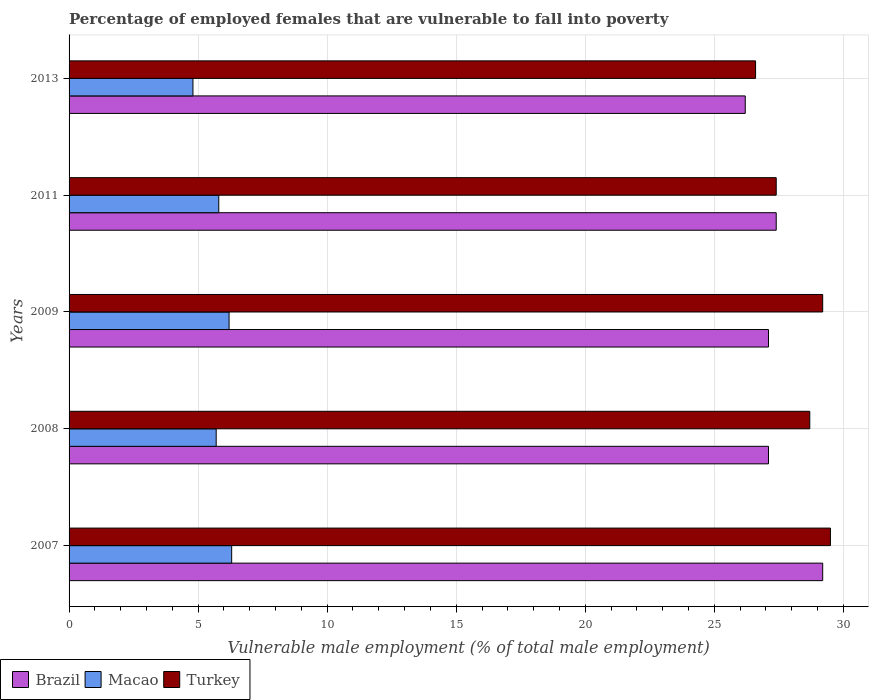How many groups of bars are there?
Your answer should be very brief. 5. Are the number of bars per tick equal to the number of legend labels?
Make the answer very short. Yes. Are the number of bars on each tick of the Y-axis equal?
Your answer should be very brief. Yes. How many bars are there on the 3rd tick from the bottom?
Make the answer very short. 3. In how many cases, is the number of bars for a given year not equal to the number of legend labels?
Offer a terse response. 0. What is the percentage of employed females who are vulnerable to fall into poverty in Brazil in 2008?
Your answer should be compact. 27.1. Across all years, what is the maximum percentage of employed females who are vulnerable to fall into poverty in Macao?
Provide a short and direct response. 6.3. Across all years, what is the minimum percentage of employed females who are vulnerable to fall into poverty in Brazil?
Provide a succinct answer. 26.2. In which year was the percentage of employed females who are vulnerable to fall into poverty in Brazil maximum?
Ensure brevity in your answer.  2007. What is the total percentage of employed females who are vulnerable to fall into poverty in Brazil in the graph?
Offer a terse response. 137. What is the difference between the percentage of employed females who are vulnerable to fall into poverty in Macao in 2007 and that in 2008?
Give a very brief answer. 0.6. What is the difference between the percentage of employed females who are vulnerable to fall into poverty in Brazil in 2007 and the percentage of employed females who are vulnerable to fall into poverty in Macao in 2013?
Offer a very short reply. 24.4. What is the average percentage of employed females who are vulnerable to fall into poverty in Brazil per year?
Keep it short and to the point. 27.4. In the year 2007, what is the difference between the percentage of employed females who are vulnerable to fall into poverty in Turkey and percentage of employed females who are vulnerable to fall into poverty in Macao?
Your response must be concise. 23.2. What is the ratio of the percentage of employed females who are vulnerable to fall into poverty in Brazil in 2008 to that in 2011?
Your response must be concise. 0.99. Is the percentage of employed females who are vulnerable to fall into poverty in Turkey in 2008 less than that in 2013?
Your answer should be very brief. No. Is the difference between the percentage of employed females who are vulnerable to fall into poverty in Turkey in 2007 and 2013 greater than the difference between the percentage of employed females who are vulnerable to fall into poverty in Macao in 2007 and 2013?
Ensure brevity in your answer.  Yes. What is the difference between the highest and the second highest percentage of employed females who are vulnerable to fall into poverty in Macao?
Provide a succinct answer. 0.1. In how many years, is the percentage of employed females who are vulnerable to fall into poverty in Brazil greater than the average percentage of employed females who are vulnerable to fall into poverty in Brazil taken over all years?
Make the answer very short. 1. What does the 2nd bar from the top in 2008 represents?
Give a very brief answer. Macao. Does the graph contain any zero values?
Offer a very short reply. No. Where does the legend appear in the graph?
Keep it short and to the point. Bottom left. What is the title of the graph?
Your answer should be compact. Percentage of employed females that are vulnerable to fall into poverty. What is the label or title of the X-axis?
Ensure brevity in your answer.  Vulnerable male employment (% of total male employment). What is the Vulnerable male employment (% of total male employment) of Brazil in 2007?
Offer a very short reply. 29.2. What is the Vulnerable male employment (% of total male employment) in Macao in 2007?
Keep it short and to the point. 6.3. What is the Vulnerable male employment (% of total male employment) of Turkey in 2007?
Make the answer very short. 29.5. What is the Vulnerable male employment (% of total male employment) of Brazil in 2008?
Offer a very short reply. 27.1. What is the Vulnerable male employment (% of total male employment) in Macao in 2008?
Your response must be concise. 5.7. What is the Vulnerable male employment (% of total male employment) of Turkey in 2008?
Keep it short and to the point. 28.7. What is the Vulnerable male employment (% of total male employment) in Brazil in 2009?
Make the answer very short. 27.1. What is the Vulnerable male employment (% of total male employment) of Macao in 2009?
Make the answer very short. 6.2. What is the Vulnerable male employment (% of total male employment) of Turkey in 2009?
Your answer should be compact. 29.2. What is the Vulnerable male employment (% of total male employment) of Brazil in 2011?
Give a very brief answer. 27.4. What is the Vulnerable male employment (% of total male employment) in Macao in 2011?
Make the answer very short. 5.8. What is the Vulnerable male employment (% of total male employment) of Turkey in 2011?
Keep it short and to the point. 27.4. What is the Vulnerable male employment (% of total male employment) in Brazil in 2013?
Your response must be concise. 26.2. What is the Vulnerable male employment (% of total male employment) in Macao in 2013?
Provide a succinct answer. 4.8. What is the Vulnerable male employment (% of total male employment) of Turkey in 2013?
Ensure brevity in your answer.  26.6. Across all years, what is the maximum Vulnerable male employment (% of total male employment) of Brazil?
Offer a terse response. 29.2. Across all years, what is the maximum Vulnerable male employment (% of total male employment) of Macao?
Your answer should be very brief. 6.3. Across all years, what is the maximum Vulnerable male employment (% of total male employment) in Turkey?
Your answer should be compact. 29.5. Across all years, what is the minimum Vulnerable male employment (% of total male employment) of Brazil?
Keep it short and to the point. 26.2. Across all years, what is the minimum Vulnerable male employment (% of total male employment) of Macao?
Ensure brevity in your answer.  4.8. Across all years, what is the minimum Vulnerable male employment (% of total male employment) in Turkey?
Provide a short and direct response. 26.6. What is the total Vulnerable male employment (% of total male employment) of Brazil in the graph?
Make the answer very short. 137. What is the total Vulnerable male employment (% of total male employment) in Macao in the graph?
Offer a very short reply. 28.8. What is the total Vulnerable male employment (% of total male employment) of Turkey in the graph?
Give a very brief answer. 141.4. What is the difference between the Vulnerable male employment (% of total male employment) in Brazil in 2007 and that in 2008?
Give a very brief answer. 2.1. What is the difference between the Vulnerable male employment (% of total male employment) in Macao in 2007 and that in 2008?
Your answer should be compact. 0.6. What is the difference between the Vulnerable male employment (% of total male employment) in Macao in 2007 and that in 2009?
Make the answer very short. 0.1. What is the difference between the Vulnerable male employment (% of total male employment) of Brazil in 2007 and that in 2013?
Make the answer very short. 3. What is the difference between the Vulnerable male employment (% of total male employment) in Macao in 2008 and that in 2009?
Your answer should be very brief. -0.5. What is the difference between the Vulnerable male employment (% of total male employment) of Turkey in 2008 and that in 2009?
Your answer should be very brief. -0.5. What is the difference between the Vulnerable male employment (% of total male employment) of Macao in 2008 and that in 2011?
Provide a short and direct response. -0.1. What is the difference between the Vulnerable male employment (% of total male employment) in Turkey in 2008 and that in 2011?
Your answer should be very brief. 1.3. What is the difference between the Vulnerable male employment (% of total male employment) in Brazil in 2008 and that in 2013?
Offer a terse response. 0.9. What is the difference between the Vulnerable male employment (% of total male employment) in Macao in 2008 and that in 2013?
Offer a very short reply. 0.9. What is the difference between the Vulnerable male employment (% of total male employment) in Brazil in 2009 and that in 2011?
Offer a terse response. -0.3. What is the difference between the Vulnerable male employment (% of total male employment) of Macao in 2009 and that in 2011?
Offer a very short reply. 0.4. What is the difference between the Vulnerable male employment (% of total male employment) of Macao in 2009 and that in 2013?
Your answer should be compact. 1.4. What is the difference between the Vulnerable male employment (% of total male employment) of Turkey in 2009 and that in 2013?
Your response must be concise. 2.6. What is the difference between the Vulnerable male employment (% of total male employment) in Brazil in 2011 and that in 2013?
Your answer should be compact. 1.2. What is the difference between the Vulnerable male employment (% of total male employment) in Turkey in 2011 and that in 2013?
Make the answer very short. 0.8. What is the difference between the Vulnerable male employment (% of total male employment) in Brazil in 2007 and the Vulnerable male employment (% of total male employment) in Macao in 2008?
Offer a terse response. 23.5. What is the difference between the Vulnerable male employment (% of total male employment) of Brazil in 2007 and the Vulnerable male employment (% of total male employment) of Turkey in 2008?
Keep it short and to the point. 0.5. What is the difference between the Vulnerable male employment (% of total male employment) of Macao in 2007 and the Vulnerable male employment (% of total male employment) of Turkey in 2008?
Your answer should be compact. -22.4. What is the difference between the Vulnerable male employment (% of total male employment) in Brazil in 2007 and the Vulnerable male employment (% of total male employment) in Macao in 2009?
Ensure brevity in your answer.  23. What is the difference between the Vulnerable male employment (% of total male employment) of Brazil in 2007 and the Vulnerable male employment (% of total male employment) of Turkey in 2009?
Your response must be concise. 0. What is the difference between the Vulnerable male employment (% of total male employment) in Macao in 2007 and the Vulnerable male employment (% of total male employment) in Turkey in 2009?
Your answer should be very brief. -22.9. What is the difference between the Vulnerable male employment (% of total male employment) in Brazil in 2007 and the Vulnerable male employment (% of total male employment) in Macao in 2011?
Ensure brevity in your answer.  23.4. What is the difference between the Vulnerable male employment (% of total male employment) of Macao in 2007 and the Vulnerable male employment (% of total male employment) of Turkey in 2011?
Offer a terse response. -21.1. What is the difference between the Vulnerable male employment (% of total male employment) in Brazil in 2007 and the Vulnerable male employment (% of total male employment) in Macao in 2013?
Offer a terse response. 24.4. What is the difference between the Vulnerable male employment (% of total male employment) in Macao in 2007 and the Vulnerable male employment (% of total male employment) in Turkey in 2013?
Your response must be concise. -20.3. What is the difference between the Vulnerable male employment (% of total male employment) of Brazil in 2008 and the Vulnerable male employment (% of total male employment) of Macao in 2009?
Your response must be concise. 20.9. What is the difference between the Vulnerable male employment (% of total male employment) in Macao in 2008 and the Vulnerable male employment (% of total male employment) in Turkey in 2009?
Ensure brevity in your answer.  -23.5. What is the difference between the Vulnerable male employment (% of total male employment) in Brazil in 2008 and the Vulnerable male employment (% of total male employment) in Macao in 2011?
Your answer should be very brief. 21.3. What is the difference between the Vulnerable male employment (% of total male employment) in Macao in 2008 and the Vulnerable male employment (% of total male employment) in Turkey in 2011?
Make the answer very short. -21.7. What is the difference between the Vulnerable male employment (% of total male employment) in Brazil in 2008 and the Vulnerable male employment (% of total male employment) in Macao in 2013?
Your answer should be very brief. 22.3. What is the difference between the Vulnerable male employment (% of total male employment) in Brazil in 2008 and the Vulnerable male employment (% of total male employment) in Turkey in 2013?
Your answer should be very brief. 0.5. What is the difference between the Vulnerable male employment (% of total male employment) of Macao in 2008 and the Vulnerable male employment (% of total male employment) of Turkey in 2013?
Provide a succinct answer. -20.9. What is the difference between the Vulnerable male employment (% of total male employment) of Brazil in 2009 and the Vulnerable male employment (% of total male employment) of Macao in 2011?
Offer a terse response. 21.3. What is the difference between the Vulnerable male employment (% of total male employment) of Macao in 2009 and the Vulnerable male employment (% of total male employment) of Turkey in 2011?
Make the answer very short. -21.2. What is the difference between the Vulnerable male employment (% of total male employment) in Brazil in 2009 and the Vulnerable male employment (% of total male employment) in Macao in 2013?
Offer a terse response. 22.3. What is the difference between the Vulnerable male employment (% of total male employment) in Brazil in 2009 and the Vulnerable male employment (% of total male employment) in Turkey in 2013?
Provide a short and direct response. 0.5. What is the difference between the Vulnerable male employment (% of total male employment) in Macao in 2009 and the Vulnerable male employment (% of total male employment) in Turkey in 2013?
Offer a very short reply. -20.4. What is the difference between the Vulnerable male employment (% of total male employment) in Brazil in 2011 and the Vulnerable male employment (% of total male employment) in Macao in 2013?
Keep it short and to the point. 22.6. What is the difference between the Vulnerable male employment (% of total male employment) in Macao in 2011 and the Vulnerable male employment (% of total male employment) in Turkey in 2013?
Offer a terse response. -20.8. What is the average Vulnerable male employment (% of total male employment) in Brazil per year?
Offer a terse response. 27.4. What is the average Vulnerable male employment (% of total male employment) in Macao per year?
Ensure brevity in your answer.  5.76. What is the average Vulnerable male employment (% of total male employment) in Turkey per year?
Provide a short and direct response. 28.28. In the year 2007, what is the difference between the Vulnerable male employment (% of total male employment) of Brazil and Vulnerable male employment (% of total male employment) of Macao?
Your answer should be compact. 22.9. In the year 2007, what is the difference between the Vulnerable male employment (% of total male employment) of Brazil and Vulnerable male employment (% of total male employment) of Turkey?
Offer a very short reply. -0.3. In the year 2007, what is the difference between the Vulnerable male employment (% of total male employment) in Macao and Vulnerable male employment (% of total male employment) in Turkey?
Your answer should be very brief. -23.2. In the year 2008, what is the difference between the Vulnerable male employment (% of total male employment) in Brazil and Vulnerable male employment (% of total male employment) in Macao?
Keep it short and to the point. 21.4. In the year 2008, what is the difference between the Vulnerable male employment (% of total male employment) in Brazil and Vulnerable male employment (% of total male employment) in Turkey?
Make the answer very short. -1.6. In the year 2008, what is the difference between the Vulnerable male employment (% of total male employment) in Macao and Vulnerable male employment (% of total male employment) in Turkey?
Your answer should be very brief. -23. In the year 2009, what is the difference between the Vulnerable male employment (% of total male employment) of Brazil and Vulnerable male employment (% of total male employment) of Macao?
Provide a short and direct response. 20.9. In the year 2011, what is the difference between the Vulnerable male employment (% of total male employment) of Brazil and Vulnerable male employment (% of total male employment) of Macao?
Your answer should be compact. 21.6. In the year 2011, what is the difference between the Vulnerable male employment (% of total male employment) of Brazil and Vulnerable male employment (% of total male employment) of Turkey?
Offer a terse response. 0. In the year 2011, what is the difference between the Vulnerable male employment (% of total male employment) of Macao and Vulnerable male employment (% of total male employment) of Turkey?
Provide a succinct answer. -21.6. In the year 2013, what is the difference between the Vulnerable male employment (% of total male employment) of Brazil and Vulnerable male employment (% of total male employment) of Macao?
Your response must be concise. 21.4. In the year 2013, what is the difference between the Vulnerable male employment (% of total male employment) in Macao and Vulnerable male employment (% of total male employment) in Turkey?
Provide a succinct answer. -21.8. What is the ratio of the Vulnerable male employment (% of total male employment) of Brazil in 2007 to that in 2008?
Provide a short and direct response. 1.08. What is the ratio of the Vulnerable male employment (% of total male employment) in Macao in 2007 to that in 2008?
Ensure brevity in your answer.  1.11. What is the ratio of the Vulnerable male employment (% of total male employment) in Turkey in 2007 to that in 2008?
Your response must be concise. 1.03. What is the ratio of the Vulnerable male employment (% of total male employment) in Brazil in 2007 to that in 2009?
Offer a very short reply. 1.08. What is the ratio of the Vulnerable male employment (% of total male employment) of Macao in 2007 to that in 2009?
Provide a succinct answer. 1.02. What is the ratio of the Vulnerable male employment (% of total male employment) in Turkey in 2007 to that in 2009?
Offer a very short reply. 1.01. What is the ratio of the Vulnerable male employment (% of total male employment) in Brazil in 2007 to that in 2011?
Give a very brief answer. 1.07. What is the ratio of the Vulnerable male employment (% of total male employment) of Macao in 2007 to that in 2011?
Offer a very short reply. 1.09. What is the ratio of the Vulnerable male employment (% of total male employment) in Turkey in 2007 to that in 2011?
Your response must be concise. 1.08. What is the ratio of the Vulnerable male employment (% of total male employment) of Brazil in 2007 to that in 2013?
Make the answer very short. 1.11. What is the ratio of the Vulnerable male employment (% of total male employment) of Macao in 2007 to that in 2013?
Keep it short and to the point. 1.31. What is the ratio of the Vulnerable male employment (% of total male employment) in Turkey in 2007 to that in 2013?
Ensure brevity in your answer.  1.11. What is the ratio of the Vulnerable male employment (% of total male employment) of Brazil in 2008 to that in 2009?
Keep it short and to the point. 1. What is the ratio of the Vulnerable male employment (% of total male employment) in Macao in 2008 to that in 2009?
Provide a short and direct response. 0.92. What is the ratio of the Vulnerable male employment (% of total male employment) of Turkey in 2008 to that in 2009?
Ensure brevity in your answer.  0.98. What is the ratio of the Vulnerable male employment (% of total male employment) of Brazil in 2008 to that in 2011?
Offer a very short reply. 0.99. What is the ratio of the Vulnerable male employment (% of total male employment) of Macao in 2008 to that in 2011?
Offer a terse response. 0.98. What is the ratio of the Vulnerable male employment (% of total male employment) of Turkey in 2008 to that in 2011?
Ensure brevity in your answer.  1.05. What is the ratio of the Vulnerable male employment (% of total male employment) in Brazil in 2008 to that in 2013?
Offer a very short reply. 1.03. What is the ratio of the Vulnerable male employment (% of total male employment) of Macao in 2008 to that in 2013?
Your answer should be very brief. 1.19. What is the ratio of the Vulnerable male employment (% of total male employment) of Turkey in 2008 to that in 2013?
Ensure brevity in your answer.  1.08. What is the ratio of the Vulnerable male employment (% of total male employment) of Macao in 2009 to that in 2011?
Provide a succinct answer. 1.07. What is the ratio of the Vulnerable male employment (% of total male employment) in Turkey in 2009 to that in 2011?
Provide a succinct answer. 1.07. What is the ratio of the Vulnerable male employment (% of total male employment) of Brazil in 2009 to that in 2013?
Ensure brevity in your answer.  1.03. What is the ratio of the Vulnerable male employment (% of total male employment) of Macao in 2009 to that in 2013?
Provide a short and direct response. 1.29. What is the ratio of the Vulnerable male employment (% of total male employment) in Turkey in 2009 to that in 2013?
Provide a short and direct response. 1.1. What is the ratio of the Vulnerable male employment (% of total male employment) in Brazil in 2011 to that in 2013?
Provide a succinct answer. 1.05. What is the ratio of the Vulnerable male employment (% of total male employment) of Macao in 2011 to that in 2013?
Keep it short and to the point. 1.21. What is the ratio of the Vulnerable male employment (% of total male employment) of Turkey in 2011 to that in 2013?
Make the answer very short. 1.03. What is the difference between the highest and the second highest Vulnerable male employment (% of total male employment) of Brazil?
Make the answer very short. 1.8. What is the difference between the highest and the second highest Vulnerable male employment (% of total male employment) of Macao?
Offer a very short reply. 0.1. What is the difference between the highest and the lowest Vulnerable male employment (% of total male employment) in Brazil?
Your answer should be very brief. 3. 